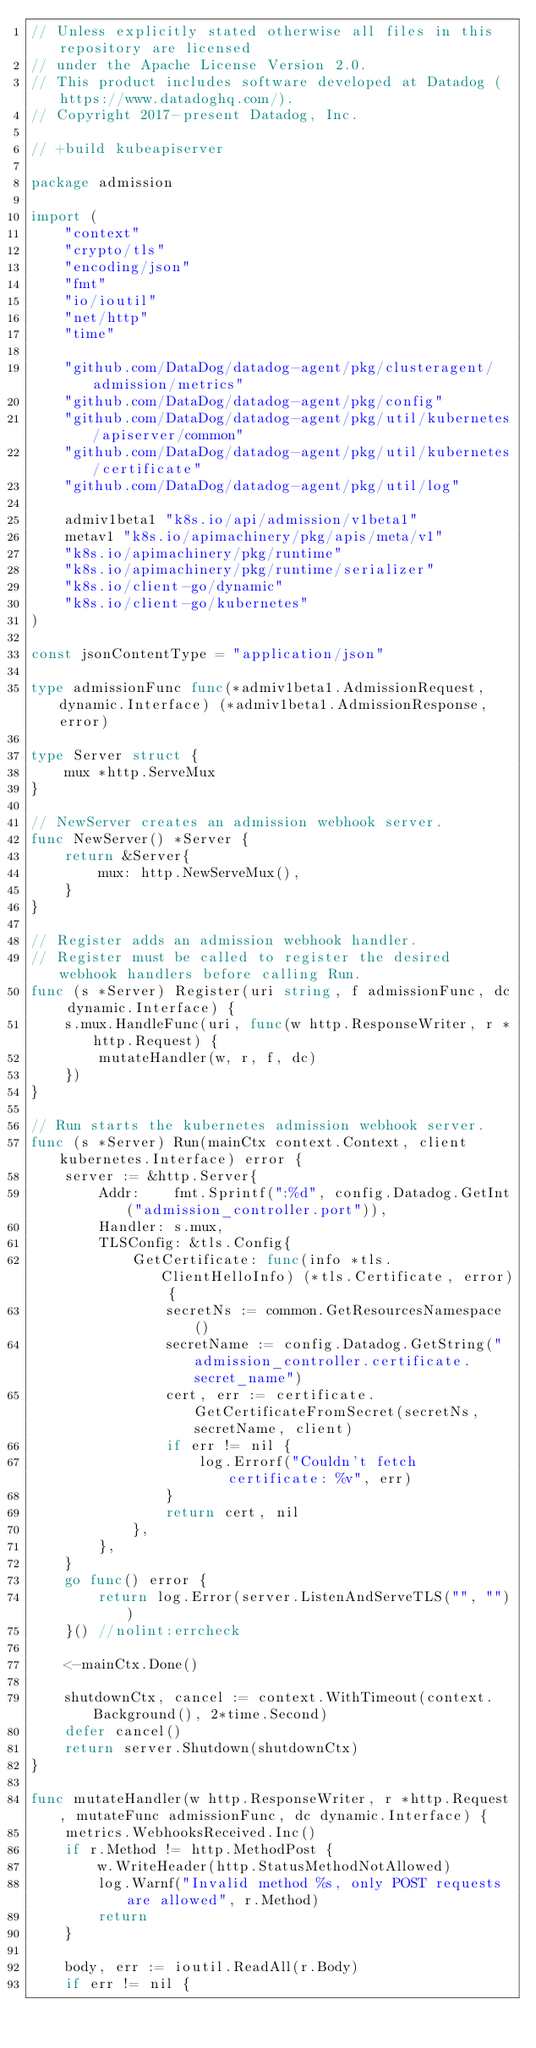Convert code to text. <code><loc_0><loc_0><loc_500><loc_500><_Go_>// Unless explicitly stated otherwise all files in this repository are licensed
// under the Apache License Version 2.0.
// This product includes software developed at Datadog (https://www.datadoghq.com/).
// Copyright 2017-present Datadog, Inc.

// +build kubeapiserver

package admission

import (
	"context"
	"crypto/tls"
	"encoding/json"
	"fmt"
	"io/ioutil"
	"net/http"
	"time"

	"github.com/DataDog/datadog-agent/pkg/clusteragent/admission/metrics"
	"github.com/DataDog/datadog-agent/pkg/config"
	"github.com/DataDog/datadog-agent/pkg/util/kubernetes/apiserver/common"
	"github.com/DataDog/datadog-agent/pkg/util/kubernetes/certificate"
	"github.com/DataDog/datadog-agent/pkg/util/log"

	admiv1beta1 "k8s.io/api/admission/v1beta1"
	metav1 "k8s.io/apimachinery/pkg/apis/meta/v1"
	"k8s.io/apimachinery/pkg/runtime"
	"k8s.io/apimachinery/pkg/runtime/serializer"
	"k8s.io/client-go/dynamic"
	"k8s.io/client-go/kubernetes"
)

const jsonContentType = "application/json"

type admissionFunc func(*admiv1beta1.AdmissionRequest, dynamic.Interface) (*admiv1beta1.AdmissionResponse, error)

type Server struct {
	mux *http.ServeMux
}

// NewServer creates an admission webhook server.
func NewServer() *Server {
	return &Server{
		mux: http.NewServeMux(),
	}
}

// Register adds an admission webhook handler.
// Register must be called to register the desired webhook handlers before calling Run.
func (s *Server) Register(uri string, f admissionFunc, dc dynamic.Interface) {
	s.mux.HandleFunc(uri, func(w http.ResponseWriter, r *http.Request) {
		mutateHandler(w, r, f, dc)
	})
}

// Run starts the kubernetes admission webhook server.
func (s *Server) Run(mainCtx context.Context, client kubernetes.Interface) error {
	server := &http.Server{
		Addr:    fmt.Sprintf(":%d", config.Datadog.GetInt("admission_controller.port")),
		Handler: s.mux,
		TLSConfig: &tls.Config{
			GetCertificate: func(info *tls.ClientHelloInfo) (*tls.Certificate, error) {
				secretNs := common.GetResourcesNamespace()
				secretName := config.Datadog.GetString("admission_controller.certificate.secret_name")
				cert, err := certificate.GetCertificateFromSecret(secretNs, secretName, client)
				if err != nil {
					log.Errorf("Couldn't fetch certificate: %v", err)
				}
				return cert, nil
			},
		},
	}
	go func() error {
		return log.Error(server.ListenAndServeTLS("", ""))
	}() //nolint:errcheck

	<-mainCtx.Done()

	shutdownCtx, cancel := context.WithTimeout(context.Background(), 2*time.Second)
	defer cancel()
	return server.Shutdown(shutdownCtx)
}

func mutateHandler(w http.ResponseWriter, r *http.Request, mutateFunc admissionFunc, dc dynamic.Interface) {
	metrics.WebhooksReceived.Inc()
	if r.Method != http.MethodPost {
		w.WriteHeader(http.StatusMethodNotAllowed)
		log.Warnf("Invalid method %s, only POST requests are allowed", r.Method)
		return
	}

	body, err := ioutil.ReadAll(r.Body)
	if err != nil {</code> 